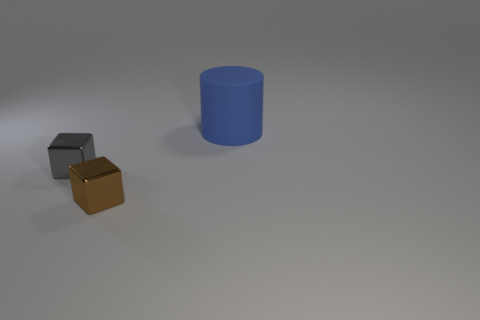Is there any other thing that has the same size as the cylinder?
Give a very brief answer. No. How many other things are there of the same material as the small gray cube?
Keep it short and to the point. 1. Are there the same number of small brown objects that are left of the gray metallic cube and large cylinders on the left side of the large blue object?
Your response must be concise. Yes. What color is the thing behind the metallic cube left of the cube to the right of the small gray metal block?
Keep it short and to the point. Blue. There is a thing in front of the small gray thing; what is its shape?
Offer a very short reply. Cube. What shape is the tiny object that is made of the same material as the gray block?
Keep it short and to the point. Cube. Is there any other thing that has the same shape as the large object?
Give a very brief answer. No. There is a gray shiny object; how many cubes are in front of it?
Offer a very short reply. 1. Are there the same number of big matte things that are to the left of the big blue cylinder and blue objects?
Give a very brief answer. No. Does the large blue thing have the same material as the small brown cube?
Make the answer very short. No. 